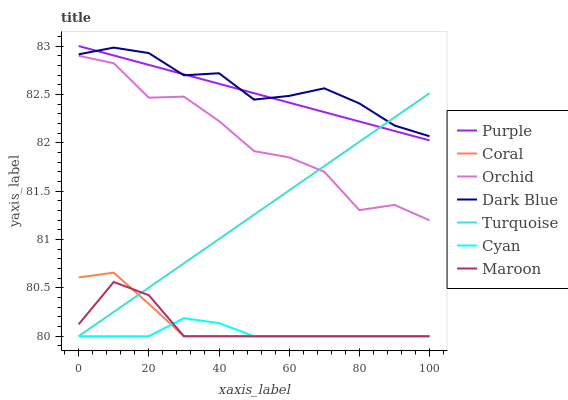Does Cyan have the minimum area under the curve?
Answer yes or no. Yes. Does Dark Blue have the maximum area under the curve?
Answer yes or no. Yes. Does Purple have the minimum area under the curve?
Answer yes or no. No. Does Purple have the maximum area under the curve?
Answer yes or no. No. Is Turquoise the smoothest?
Answer yes or no. Yes. Is Orchid the roughest?
Answer yes or no. Yes. Is Purple the smoothest?
Answer yes or no. No. Is Purple the roughest?
Answer yes or no. No. Does Turquoise have the lowest value?
Answer yes or no. Yes. Does Purple have the lowest value?
Answer yes or no. No. Does Purple have the highest value?
Answer yes or no. Yes. Does Coral have the highest value?
Answer yes or no. No. Is Orchid less than Purple?
Answer yes or no. Yes. Is Orchid greater than Maroon?
Answer yes or no. Yes. Does Turquoise intersect Orchid?
Answer yes or no. Yes. Is Turquoise less than Orchid?
Answer yes or no. No. Is Turquoise greater than Orchid?
Answer yes or no. No. Does Orchid intersect Purple?
Answer yes or no. No. 